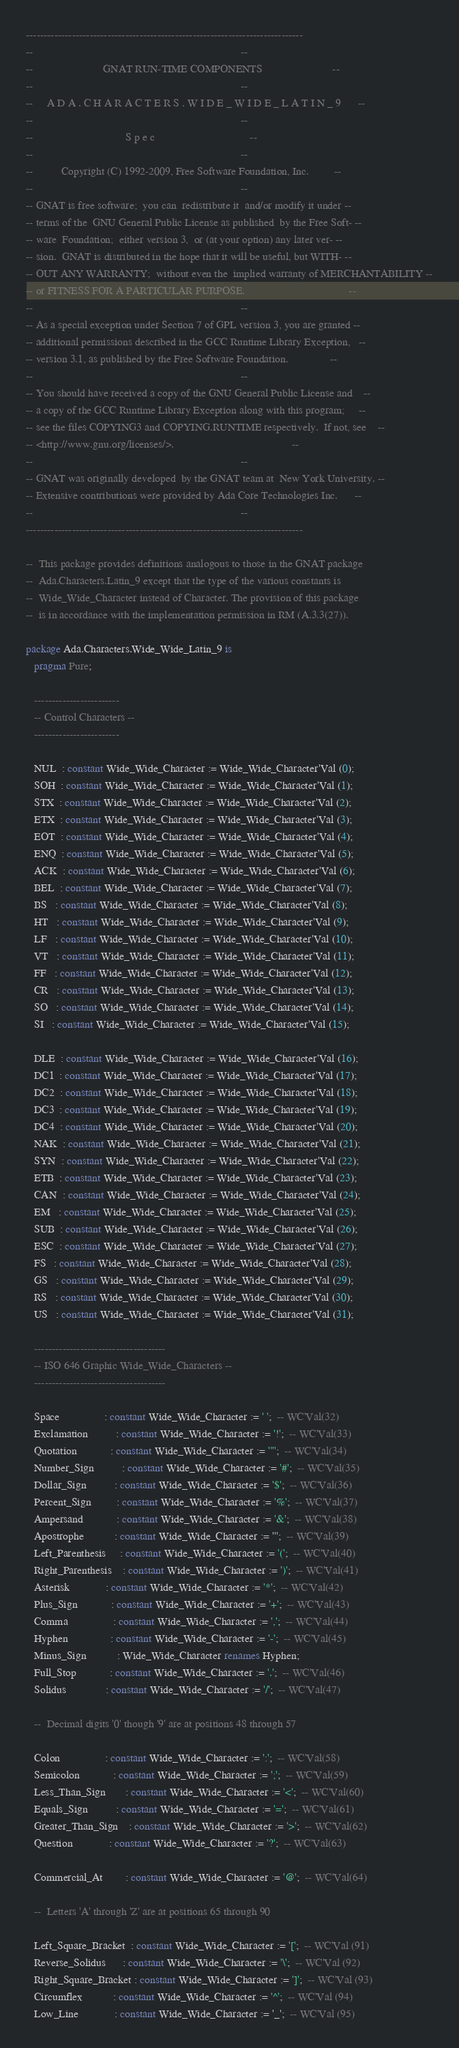Convert code to text. <code><loc_0><loc_0><loc_500><loc_500><_Ada_>------------------------------------------------------------------------------
--                                                                          --
--                         GNAT RUN-TIME COMPONENTS                         --
--                                                                          --
--     A D A . C H A R A C T E R S . W I D E _ W I D E _ L A T I N _ 9      --
--                                                                          --
--                                 S p e c                                  --
--                                                                          --
--          Copyright (C) 1992-2009, Free Software Foundation, Inc.         --
--                                                                          --
-- GNAT is free software;  you can  redistribute it  and/or modify it under --
-- terms of the  GNU General Public License as published  by the Free Soft- --
-- ware  Foundation;  either version 3,  or (at your option) any later ver- --
-- sion.  GNAT is distributed in the hope that it will be useful, but WITH- --
-- OUT ANY WARRANTY;  without even the  implied warranty of MERCHANTABILITY --
-- or FITNESS FOR A PARTICULAR PURPOSE.                                     --
--                                                                          --
-- As a special exception under Section 7 of GPL version 3, you are granted --
-- additional permissions described in the GCC Runtime Library Exception,   --
-- version 3.1, as published by the Free Software Foundation.               --
--                                                                          --
-- You should have received a copy of the GNU General Public License and    --
-- a copy of the GCC Runtime Library Exception along with this program;     --
-- see the files COPYING3 and COPYING.RUNTIME respectively.  If not, see    --
-- <http://www.gnu.org/licenses/>.                                          --
--                                                                          --
-- GNAT was originally developed  by the GNAT team at  New York University. --
-- Extensive contributions were provided by Ada Core Technologies Inc.      --
--                                                                          --
------------------------------------------------------------------------------

--  This package provides definitions analogous to those in the GNAT package
--  Ada.Characters.Latin_9 except that the type of the various constants is
--  Wide_Wide_Character instead of Character. The provision of this package
--  is in accordance with the implementation permission in RM (A.3.3(27)).

package Ada.Characters.Wide_Wide_Latin_9 is
   pragma Pure;

   ------------------------
   -- Control Characters --
   ------------------------

   NUL  : constant Wide_Wide_Character := Wide_Wide_Character'Val (0);
   SOH  : constant Wide_Wide_Character := Wide_Wide_Character'Val (1);
   STX  : constant Wide_Wide_Character := Wide_Wide_Character'Val (2);
   ETX  : constant Wide_Wide_Character := Wide_Wide_Character'Val (3);
   EOT  : constant Wide_Wide_Character := Wide_Wide_Character'Val (4);
   ENQ  : constant Wide_Wide_Character := Wide_Wide_Character'Val (5);
   ACK  : constant Wide_Wide_Character := Wide_Wide_Character'Val (6);
   BEL  : constant Wide_Wide_Character := Wide_Wide_Character'Val (7);
   BS   : constant Wide_Wide_Character := Wide_Wide_Character'Val (8);
   HT   : constant Wide_Wide_Character := Wide_Wide_Character'Val (9);
   LF   : constant Wide_Wide_Character := Wide_Wide_Character'Val (10);
   VT   : constant Wide_Wide_Character := Wide_Wide_Character'Val (11);
   FF   : constant Wide_Wide_Character := Wide_Wide_Character'Val (12);
   CR   : constant Wide_Wide_Character := Wide_Wide_Character'Val (13);
   SO   : constant Wide_Wide_Character := Wide_Wide_Character'Val (14);
   SI   : constant Wide_Wide_Character := Wide_Wide_Character'Val (15);

   DLE  : constant Wide_Wide_Character := Wide_Wide_Character'Val (16);
   DC1  : constant Wide_Wide_Character := Wide_Wide_Character'Val (17);
   DC2  : constant Wide_Wide_Character := Wide_Wide_Character'Val (18);
   DC3  : constant Wide_Wide_Character := Wide_Wide_Character'Val (19);
   DC4  : constant Wide_Wide_Character := Wide_Wide_Character'Val (20);
   NAK  : constant Wide_Wide_Character := Wide_Wide_Character'Val (21);
   SYN  : constant Wide_Wide_Character := Wide_Wide_Character'Val (22);
   ETB  : constant Wide_Wide_Character := Wide_Wide_Character'Val (23);
   CAN  : constant Wide_Wide_Character := Wide_Wide_Character'Val (24);
   EM   : constant Wide_Wide_Character := Wide_Wide_Character'Val (25);
   SUB  : constant Wide_Wide_Character := Wide_Wide_Character'Val (26);
   ESC  : constant Wide_Wide_Character := Wide_Wide_Character'Val (27);
   FS   : constant Wide_Wide_Character := Wide_Wide_Character'Val (28);
   GS   : constant Wide_Wide_Character := Wide_Wide_Character'Val (29);
   RS   : constant Wide_Wide_Character := Wide_Wide_Character'Val (30);
   US   : constant Wide_Wide_Character := Wide_Wide_Character'Val (31);

   -------------------------------------
   -- ISO 646 Graphic Wide_Wide_Characters --
   -------------------------------------

   Space                : constant Wide_Wide_Character := ' ';  -- WC'Val(32)
   Exclamation          : constant Wide_Wide_Character := '!';  -- WC'Val(33)
   Quotation            : constant Wide_Wide_Character := '"';  -- WC'Val(34)
   Number_Sign          : constant Wide_Wide_Character := '#';  -- WC'Val(35)
   Dollar_Sign          : constant Wide_Wide_Character := '$';  -- WC'Val(36)
   Percent_Sign         : constant Wide_Wide_Character := '%';  -- WC'Val(37)
   Ampersand            : constant Wide_Wide_Character := '&';  -- WC'Val(38)
   Apostrophe           : constant Wide_Wide_Character := ''';  -- WC'Val(39)
   Left_Parenthesis     : constant Wide_Wide_Character := '(';  -- WC'Val(40)
   Right_Parenthesis    : constant Wide_Wide_Character := ')';  -- WC'Val(41)
   Asterisk             : constant Wide_Wide_Character := '*';  -- WC'Val(42)
   Plus_Sign            : constant Wide_Wide_Character := '+';  -- WC'Val(43)
   Comma                : constant Wide_Wide_Character := ',';  -- WC'Val(44)
   Hyphen               : constant Wide_Wide_Character := '-';  -- WC'Val(45)
   Minus_Sign           : Wide_Wide_Character renames Hyphen;
   Full_Stop            : constant Wide_Wide_Character := '.';  -- WC'Val(46)
   Solidus              : constant Wide_Wide_Character := '/';  -- WC'Val(47)

   --  Decimal digits '0' though '9' are at positions 48 through 57

   Colon                : constant Wide_Wide_Character := ':';  -- WC'Val(58)
   Semicolon            : constant Wide_Wide_Character := ';';  -- WC'Val(59)
   Less_Than_Sign       : constant Wide_Wide_Character := '<';  -- WC'Val(60)
   Equals_Sign          : constant Wide_Wide_Character := '=';  -- WC'Val(61)
   Greater_Than_Sign    : constant Wide_Wide_Character := '>';  -- WC'Val(62)
   Question             : constant Wide_Wide_Character := '?';  -- WC'Val(63)

   Commercial_At        : constant Wide_Wide_Character := '@';  -- WC'Val(64)

   --  Letters 'A' through 'Z' are at positions 65 through 90

   Left_Square_Bracket  : constant Wide_Wide_Character := '[';  -- WC'Val (91)
   Reverse_Solidus      : constant Wide_Wide_Character := '\';  -- WC'Val (92)
   Right_Square_Bracket : constant Wide_Wide_Character := ']';  -- WC'Val (93)
   Circumflex           : constant Wide_Wide_Character := '^';  -- WC'Val (94)
   Low_Line             : constant Wide_Wide_Character := '_';  -- WC'Val (95)
</code> 